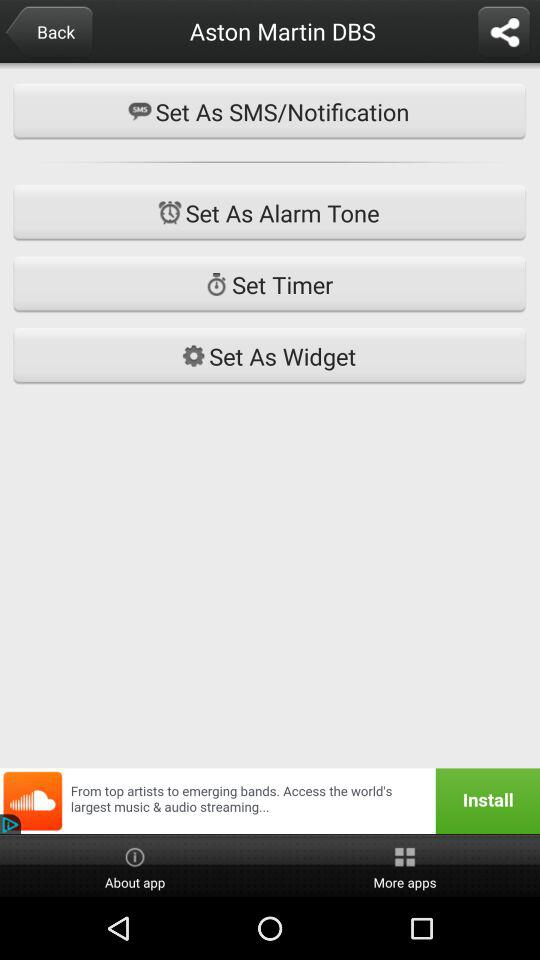What is the application name?
When the provided information is insufficient, respond with <no answer>. <no answer> 